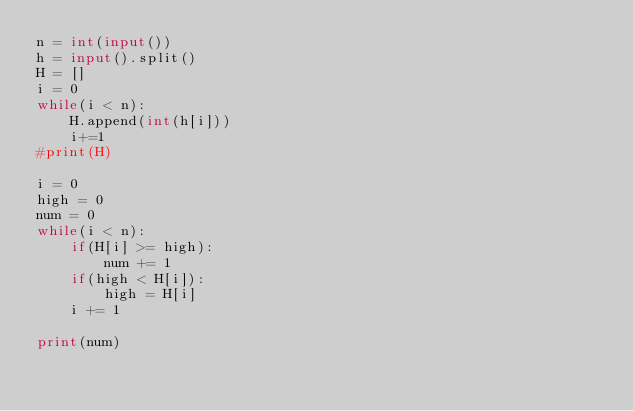<code> <loc_0><loc_0><loc_500><loc_500><_Python_>n = int(input())
h = input().split()
H = []
i = 0
while(i < n):
    H.append(int(h[i]))
    i+=1
#print(H)

i = 0
high = 0
num = 0
while(i < n):
    if(H[i] >= high):
        num += 1
    if(high < H[i]):
        high = H[i]
    i += 1

print(num)</code> 